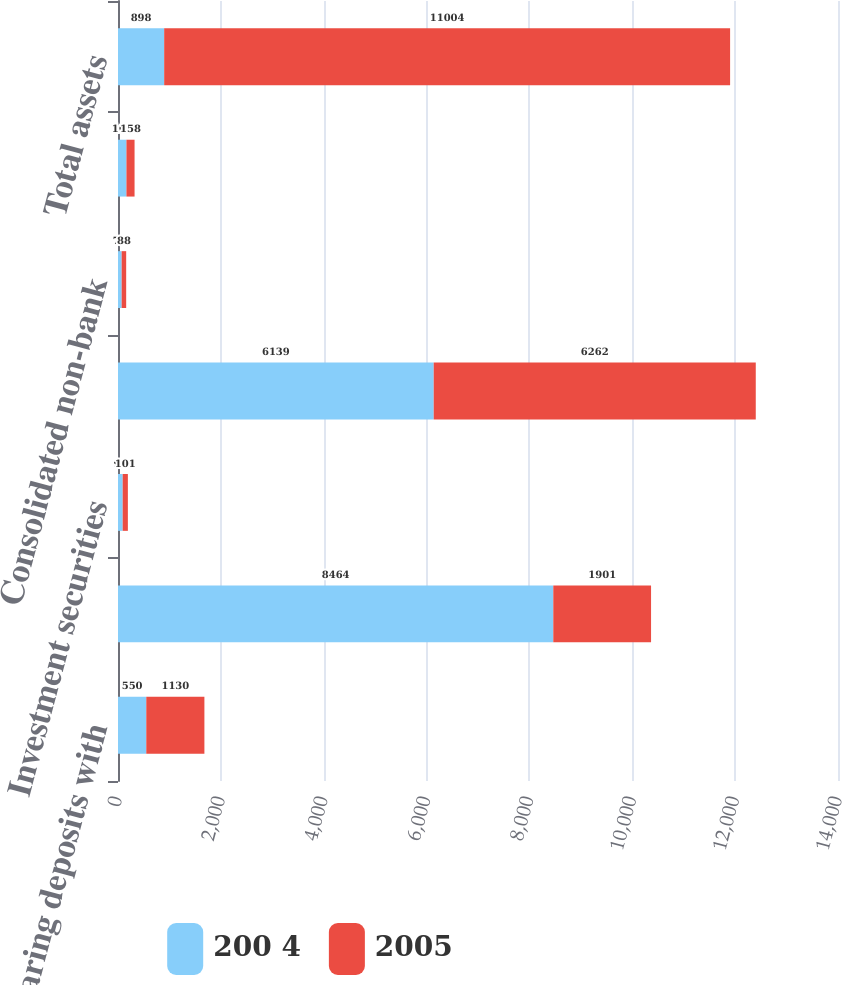Convert chart to OTSL. <chart><loc_0><loc_0><loc_500><loc_500><stacked_bar_chart><ecel><fcel>Interest-bearing deposits with<fcel>External parties<fcel>Investment securities<fcel>Consolidated bank subsidiary<fcel>Consolidated non-bank<fcel>Unconsolidated affiliates<fcel>Total assets<nl><fcel>200 4<fcel>550<fcel>8464<fcel>91<fcel>6139<fcel>71<fcel>164<fcel>898<nl><fcel>2005<fcel>1130<fcel>1901<fcel>101<fcel>6262<fcel>88<fcel>158<fcel>11004<nl></chart> 